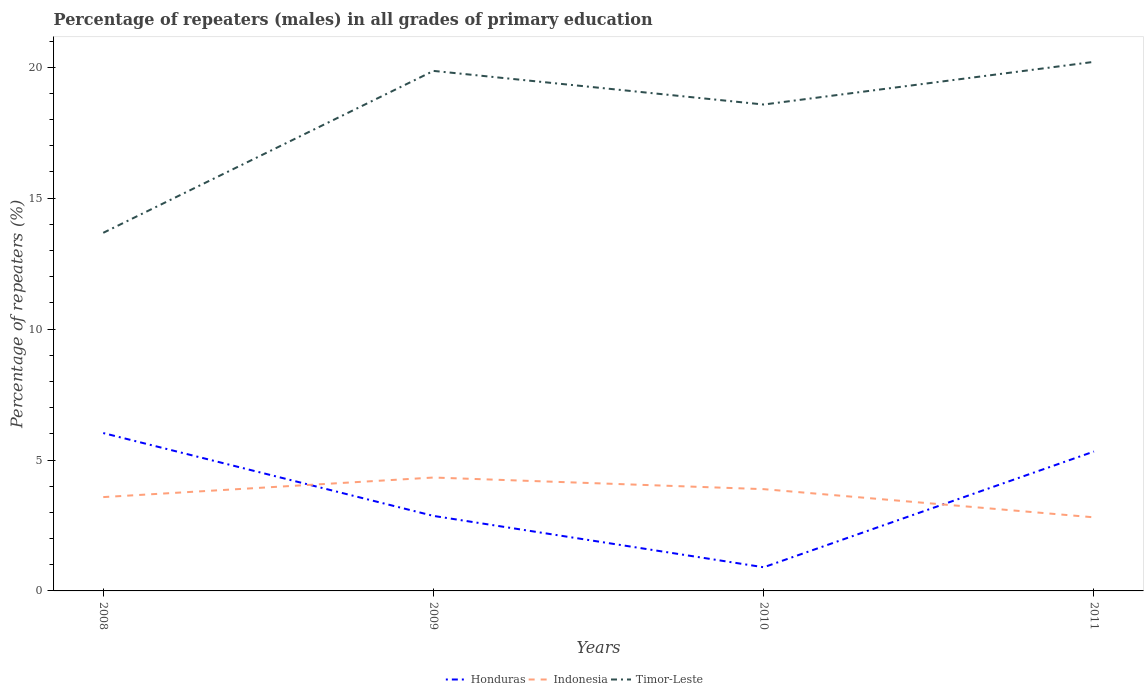How many different coloured lines are there?
Ensure brevity in your answer.  3. Across all years, what is the maximum percentage of repeaters (males) in Timor-Leste?
Your answer should be very brief. 13.68. What is the total percentage of repeaters (males) in Indonesia in the graph?
Your response must be concise. -0.75. What is the difference between the highest and the second highest percentage of repeaters (males) in Indonesia?
Your answer should be compact. 1.52. What is the difference between the highest and the lowest percentage of repeaters (males) in Indonesia?
Ensure brevity in your answer.  2. Is the percentage of repeaters (males) in Honduras strictly greater than the percentage of repeaters (males) in Indonesia over the years?
Your answer should be compact. No. Does the graph contain grids?
Your answer should be very brief. No. Where does the legend appear in the graph?
Offer a terse response. Bottom center. How are the legend labels stacked?
Make the answer very short. Horizontal. What is the title of the graph?
Keep it short and to the point. Percentage of repeaters (males) in all grades of primary education. What is the label or title of the Y-axis?
Keep it short and to the point. Percentage of repeaters (%). What is the Percentage of repeaters (%) of Honduras in 2008?
Offer a terse response. 6.03. What is the Percentage of repeaters (%) of Indonesia in 2008?
Offer a terse response. 3.58. What is the Percentage of repeaters (%) of Timor-Leste in 2008?
Provide a short and direct response. 13.68. What is the Percentage of repeaters (%) in Honduras in 2009?
Ensure brevity in your answer.  2.87. What is the Percentage of repeaters (%) of Indonesia in 2009?
Your answer should be compact. 4.33. What is the Percentage of repeaters (%) in Timor-Leste in 2009?
Your answer should be compact. 19.86. What is the Percentage of repeaters (%) of Honduras in 2010?
Offer a very short reply. 0.9. What is the Percentage of repeaters (%) of Indonesia in 2010?
Offer a very short reply. 3.89. What is the Percentage of repeaters (%) in Timor-Leste in 2010?
Your answer should be compact. 18.58. What is the Percentage of repeaters (%) of Honduras in 2011?
Your response must be concise. 5.32. What is the Percentage of repeaters (%) in Indonesia in 2011?
Offer a very short reply. 2.81. What is the Percentage of repeaters (%) in Timor-Leste in 2011?
Give a very brief answer. 20.21. Across all years, what is the maximum Percentage of repeaters (%) in Honduras?
Provide a succinct answer. 6.03. Across all years, what is the maximum Percentage of repeaters (%) in Indonesia?
Your response must be concise. 4.33. Across all years, what is the maximum Percentage of repeaters (%) in Timor-Leste?
Make the answer very short. 20.21. Across all years, what is the minimum Percentage of repeaters (%) in Honduras?
Provide a succinct answer. 0.9. Across all years, what is the minimum Percentage of repeaters (%) in Indonesia?
Provide a succinct answer. 2.81. Across all years, what is the minimum Percentage of repeaters (%) in Timor-Leste?
Ensure brevity in your answer.  13.68. What is the total Percentage of repeaters (%) in Honduras in the graph?
Provide a short and direct response. 15.12. What is the total Percentage of repeaters (%) of Indonesia in the graph?
Provide a succinct answer. 14.61. What is the total Percentage of repeaters (%) in Timor-Leste in the graph?
Keep it short and to the point. 72.32. What is the difference between the Percentage of repeaters (%) of Honduras in 2008 and that in 2009?
Your response must be concise. 3.16. What is the difference between the Percentage of repeaters (%) in Indonesia in 2008 and that in 2009?
Provide a short and direct response. -0.75. What is the difference between the Percentage of repeaters (%) in Timor-Leste in 2008 and that in 2009?
Give a very brief answer. -6.18. What is the difference between the Percentage of repeaters (%) in Honduras in 2008 and that in 2010?
Your response must be concise. 5.13. What is the difference between the Percentage of repeaters (%) in Indonesia in 2008 and that in 2010?
Your response must be concise. -0.3. What is the difference between the Percentage of repeaters (%) in Timor-Leste in 2008 and that in 2010?
Keep it short and to the point. -4.9. What is the difference between the Percentage of repeaters (%) of Honduras in 2008 and that in 2011?
Offer a terse response. 0.71. What is the difference between the Percentage of repeaters (%) in Indonesia in 2008 and that in 2011?
Your response must be concise. 0.77. What is the difference between the Percentage of repeaters (%) of Timor-Leste in 2008 and that in 2011?
Keep it short and to the point. -6.53. What is the difference between the Percentage of repeaters (%) of Honduras in 2009 and that in 2010?
Your answer should be very brief. 1.96. What is the difference between the Percentage of repeaters (%) in Indonesia in 2009 and that in 2010?
Provide a short and direct response. 0.44. What is the difference between the Percentage of repeaters (%) of Timor-Leste in 2009 and that in 2010?
Offer a very short reply. 1.28. What is the difference between the Percentage of repeaters (%) in Honduras in 2009 and that in 2011?
Keep it short and to the point. -2.46. What is the difference between the Percentage of repeaters (%) of Indonesia in 2009 and that in 2011?
Offer a terse response. 1.52. What is the difference between the Percentage of repeaters (%) of Timor-Leste in 2009 and that in 2011?
Ensure brevity in your answer.  -0.35. What is the difference between the Percentage of repeaters (%) of Honduras in 2010 and that in 2011?
Give a very brief answer. -4.42. What is the difference between the Percentage of repeaters (%) of Indonesia in 2010 and that in 2011?
Ensure brevity in your answer.  1.08. What is the difference between the Percentage of repeaters (%) of Timor-Leste in 2010 and that in 2011?
Your answer should be compact. -1.63. What is the difference between the Percentage of repeaters (%) of Honduras in 2008 and the Percentage of repeaters (%) of Indonesia in 2009?
Your answer should be very brief. 1.7. What is the difference between the Percentage of repeaters (%) in Honduras in 2008 and the Percentage of repeaters (%) in Timor-Leste in 2009?
Give a very brief answer. -13.83. What is the difference between the Percentage of repeaters (%) in Indonesia in 2008 and the Percentage of repeaters (%) in Timor-Leste in 2009?
Ensure brevity in your answer.  -16.28. What is the difference between the Percentage of repeaters (%) in Honduras in 2008 and the Percentage of repeaters (%) in Indonesia in 2010?
Provide a succinct answer. 2.14. What is the difference between the Percentage of repeaters (%) in Honduras in 2008 and the Percentage of repeaters (%) in Timor-Leste in 2010?
Offer a terse response. -12.55. What is the difference between the Percentage of repeaters (%) in Indonesia in 2008 and the Percentage of repeaters (%) in Timor-Leste in 2010?
Give a very brief answer. -14.99. What is the difference between the Percentage of repeaters (%) of Honduras in 2008 and the Percentage of repeaters (%) of Indonesia in 2011?
Ensure brevity in your answer.  3.22. What is the difference between the Percentage of repeaters (%) in Honduras in 2008 and the Percentage of repeaters (%) in Timor-Leste in 2011?
Provide a short and direct response. -14.18. What is the difference between the Percentage of repeaters (%) in Indonesia in 2008 and the Percentage of repeaters (%) in Timor-Leste in 2011?
Provide a succinct answer. -16.62. What is the difference between the Percentage of repeaters (%) in Honduras in 2009 and the Percentage of repeaters (%) in Indonesia in 2010?
Keep it short and to the point. -1.02. What is the difference between the Percentage of repeaters (%) in Honduras in 2009 and the Percentage of repeaters (%) in Timor-Leste in 2010?
Your response must be concise. -15.71. What is the difference between the Percentage of repeaters (%) in Indonesia in 2009 and the Percentage of repeaters (%) in Timor-Leste in 2010?
Your answer should be compact. -14.25. What is the difference between the Percentage of repeaters (%) in Honduras in 2009 and the Percentage of repeaters (%) in Indonesia in 2011?
Provide a succinct answer. 0.05. What is the difference between the Percentage of repeaters (%) in Honduras in 2009 and the Percentage of repeaters (%) in Timor-Leste in 2011?
Keep it short and to the point. -17.34. What is the difference between the Percentage of repeaters (%) in Indonesia in 2009 and the Percentage of repeaters (%) in Timor-Leste in 2011?
Give a very brief answer. -15.88. What is the difference between the Percentage of repeaters (%) of Honduras in 2010 and the Percentage of repeaters (%) of Indonesia in 2011?
Keep it short and to the point. -1.91. What is the difference between the Percentage of repeaters (%) in Honduras in 2010 and the Percentage of repeaters (%) in Timor-Leste in 2011?
Your answer should be compact. -19.3. What is the difference between the Percentage of repeaters (%) in Indonesia in 2010 and the Percentage of repeaters (%) in Timor-Leste in 2011?
Make the answer very short. -16.32. What is the average Percentage of repeaters (%) of Honduras per year?
Offer a terse response. 3.78. What is the average Percentage of repeaters (%) in Indonesia per year?
Make the answer very short. 3.65. What is the average Percentage of repeaters (%) in Timor-Leste per year?
Your answer should be very brief. 18.08. In the year 2008, what is the difference between the Percentage of repeaters (%) of Honduras and Percentage of repeaters (%) of Indonesia?
Make the answer very short. 2.45. In the year 2008, what is the difference between the Percentage of repeaters (%) of Honduras and Percentage of repeaters (%) of Timor-Leste?
Your response must be concise. -7.65. In the year 2008, what is the difference between the Percentage of repeaters (%) of Indonesia and Percentage of repeaters (%) of Timor-Leste?
Offer a terse response. -10.09. In the year 2009, what is the difference between the Percentage of repeaters (%) of Honduras and Percentage of repeaters (%) of Indonesia?
Your answer should be compact. -1.47. In the year 2009, what is the difference between the Percentage of repeaters (%) of Honduras and Percentage of repeaters (%) of Timor-Leste?
Keep it short and to the point. -17. In the year 2009, what is the difference between the Percentage of repeaters (%) in Indonesia and Percentage of repeaters (%) in Timor-Leste?
Keep it short and to the point. -15.53. In the year 2010, what is the difference between the Percentage of repeaters (%) in Honduras and Percentage of repeaters (%) in Indonesia?
Ensure brevity in your answer.  -2.98. In the year 2010, what is the difference between the Percentage of repeaters (%) of Honduras and Percentage of repeaters (%) of Timor-Leste?
Keep it short and to the point. -17.67. In the year 2010, what is the difference between the Percentage of repeaters (%) of Indonesia and Percentage of repeaters (%) of Timor-Leste?
Your response must be concise. -14.69. In the year 2011, what is the difference between the Percentage of repeaters (%) in Honduras and Percentage of repeaters (%) in Indonesia?
Make the answer very short. 2.51. In the year 2011, what is the difference between the Percentage of repeaters (%) of Honduras and Percentage of repeaters (%) of Timor-Leste?
Offer a very short reply. -14.88. In the year 2011, what is the difference between the Percentage of repeaters (%) in Indonesia and Percentage of repeaters (%) in Timor-Leste?
Provide a succinct answer. -17.4. What is the ratio of the Percentage of repeaters (%) of Honduras in 2008 to that in 2009?
Offer a terse response. 2.1. What is the ratio of the Percentage of repeaters (%) in Indonesia in 2008 to that in 2009?
Ensure brevity in your answer.  0.83. What is the ratio of the Percentage of repeaters (%) of Timor-Leste in 2008 to that in 2009?
Give a very brief answer. 0.69. What is the ratio of the Percentage of repeaters (%) in Honduras in 2008 to that in 2010?
Your response must be concise. 6.67. What is the ratio of the Percentage of repeaters (%) in Indonesia in 2008 to that in 2010?
Keep it short and to the point. 0.92. What is the ratio of the Percentage of repeaters (%) in Timor-Leste in 2008 to that in 2010?
Your answer should be very brief. 0.74. What is the ratio of the Percentage of repeaters (%) in Honduras in 2008 to that in 2011?
Your answer should be compact. 1.13. What is the ratio of the Percentage of repeaters (%) of Indonesia in 2008 to that in 2011?
Your answer should be very brief. 1.28. What is the ratio of the Percentage of repeaters (%) in Timor-Leste in 2008 to that in 2011?
Give a very brief answer. 0.68. What is the ratio of the Percentage of repeaters (%) in Honduras in 2009 to that in 2010?
Ensure brevity in your answer.  3.17. What is the ratio of the Percentage of repeaters (%) in Indonesia in 2009 to that in 2010?
Provide a short and direct response. 1.11. What is the ratio of the Percentage of repeaters (%) of Timor-Leste in 2009 to that in 2010?
Provide a short and direct response. 1.07. What is the ratio of the Percentage of repeaters (%) in Honduras in 2009 to that in 2011?
Your answer should be compact. 0.54. What is the ratio of the Percentage of repeaters (%) in Indonesia in 2009 to that in 2011?
Your answer should be very brief. 1.54. What is the ratio of the Percentage of repeaters (%) of Timor-Leste in 2009 to that in 2011?
Make the answer very short. 0.98. What is the ratio of the Percentage of repeaters (%) in Honduras in 2010 to that in 2011?
Give a very brief answer. 0.17. What is the ratio of the Percentage of repeaters (%) of Indonesia in 2010 to that in 2011?
Provide a succinct answer. 1.38. What is the ratio of the Percentage of repeaters (%) in Timor-Leste in 2010 to that in 2011?
Ensure brevity in your answer.  0.92. What is the difference between the highest and the second highest Percentage of repeaters (%) of Honduras?
Provide a succinct answer. 0.71. What is the difference between the highest and the second highest Percentage of repeaters (%) in Indonesia?
Keep it short and to the point. 0.44. What is the difference between the highest and the second highest Percentage of repeaters (%) in Timor-Leste?
Your answer should be compact. 0.35. What is the difference between the highest and the lowest Percentage of repeaters (%) in Honduras?
Your answer should be very brief. 5.13. What is the difference between the highest and the lowest Percentage of repeaters (%) in Indonesia?
Your answer should be compact. 1.52. What is the difference between the highest and the lowest Percentage of repeaters (%) in Timor-Leste?
Ensure brevity in your answer.  6.53. 